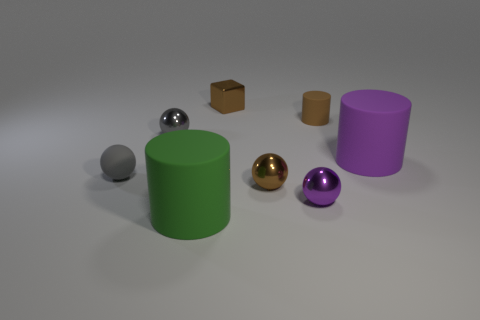There is a matte sphere; is its color the same as the tiny shiny ball left of the small brown metal sphere?
Give a very brief answer. Yes. There is a rubber thing that is behind the purple rubber cylinder; is its color the same as the small block?
Your answer should be compact. Yes. Are there any things of the same color as the tiny cylinder?
Keep it short and to the point. Yes. Does the small cylinder have the same color as the tiny cube?
Your response must be concise. Yes. What is the shape of the small shiny object that is the same color as the rubber ball?
Your answer should be compact. Sphere. Are there any matte objects to the right of the brown shiny cube?
Your response must be concise. Yes. There is a metal cube that is the same size as the brown rubber thing; what color is it?
Give a very brief answer. Brown. What number of objects are either tiny brown objects that are in front of the large purple cylinder or green cylinders?
Ensure brevity in your answer.  2. There is a matte cylinder that is both in front of the tiny brown rubber cylinder and on the right side of the big green rubber thing; how big is it?
Your answer should be very brief. Large. How many other things are the same size as the purple metallic sphere?
Offer a terse response. 5. 